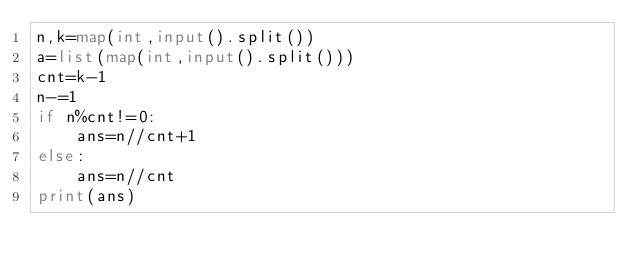<code> <loc_0><loc_0><loc_500><loc_500><_Python_>n,k=map(int,input().split())
a=list(map(int,input().split()))
cnt=k-1
n-=1
if n%cnt!=0:
    ans=n//cnt+1
else:
    ans=n//cnt
print(ans)
</code> 